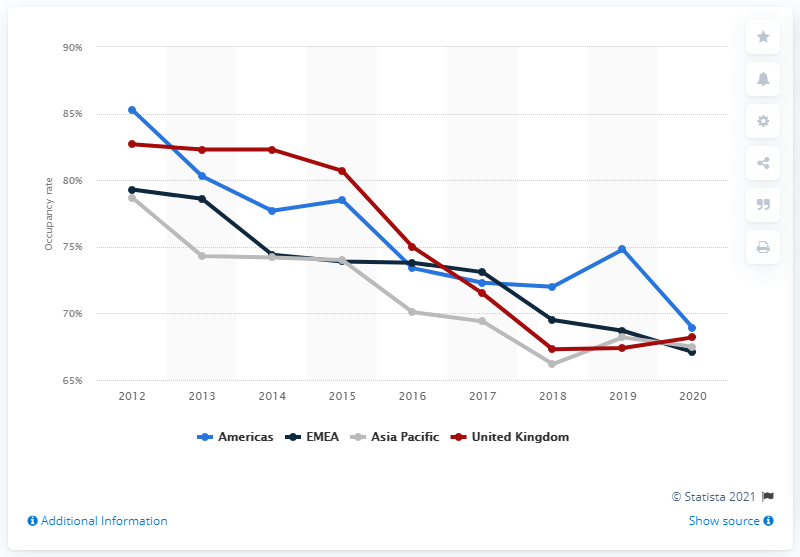Give some essential details in this illustration. In 2020, the occupancy rate of IWG's workstations in the Americas was 68.9%. 